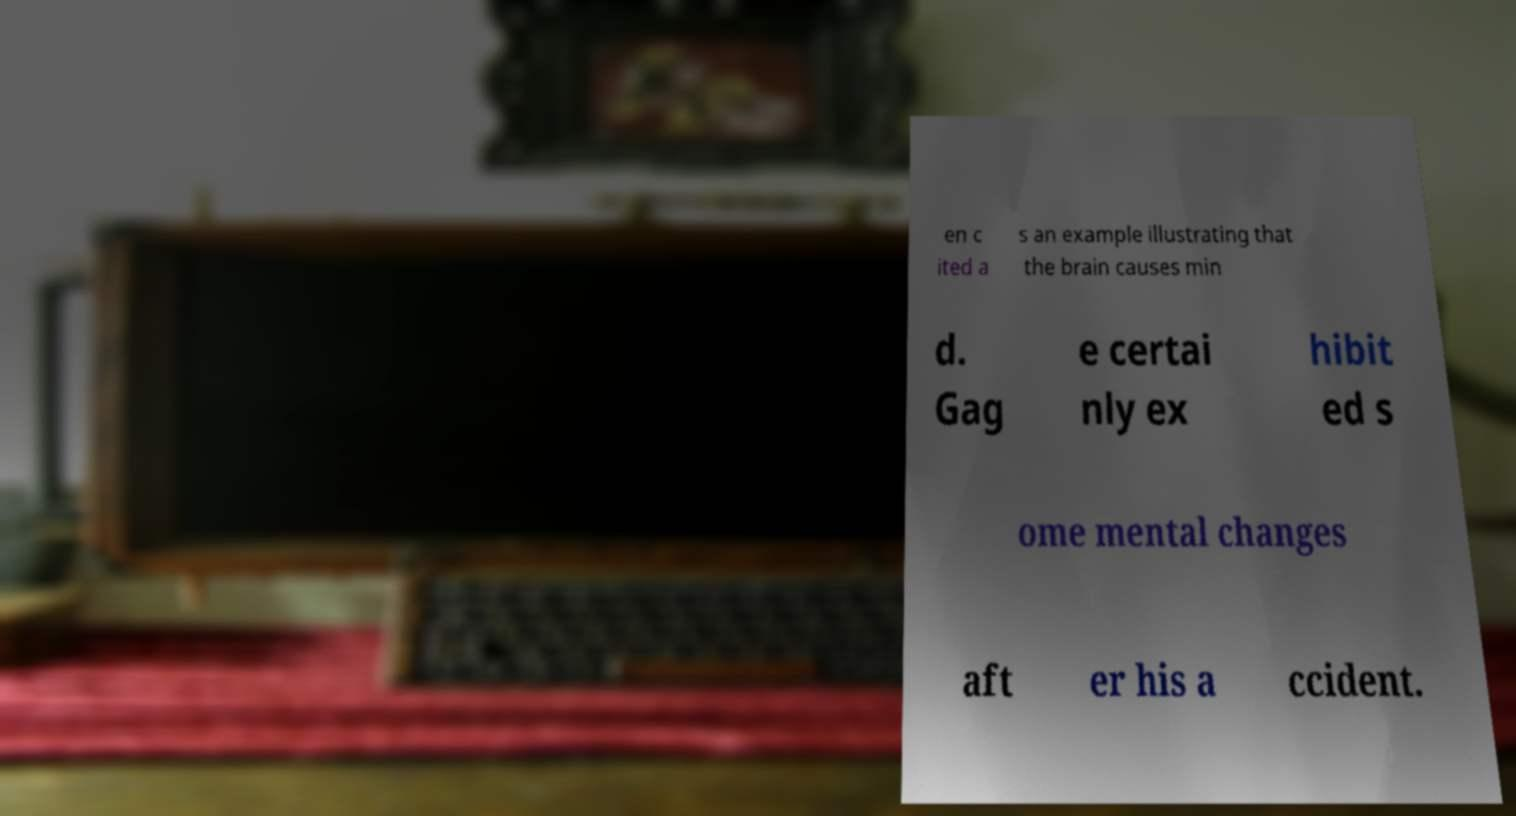For documentation purposes, I need the text within this image transcribed. Could you provide that? en c ited a s an example illustrating that the brain causes min d. Gag e certai nly ex hibit ed s ome mental changes aft er his a ccident. 